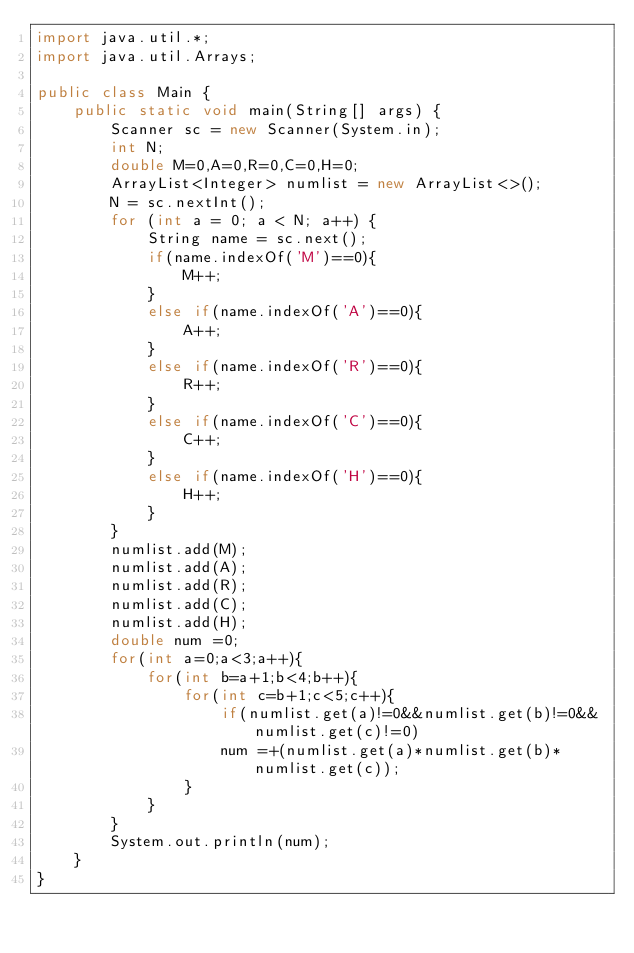Convert code to text. <code><loc_0><loc_0><loc_500><loc_500><_Java_>import java.util.*;
import java.util.Arrays;

public class Main {
    public static void main(String[] args) {
        Scanner sc = new Scanner(System.in);
        int N;
        double M=0,A=0,R=0,C=0,H=0;
        ArrayList<Integer> numlist = new ArrayList<>();
        N = sc.nextInt();
        for (int a = 0; a < N; a++) {
            String name = sc.next();
            if(name.indexOf('M')==0){
                M++;
            }
            else if(name.indexOf('A')==0){
                A++;
            }
            else if(name.indexOf('R')==0){
                R++;
            }
            else if(name.indexOf('C')==0){
                C++;
            }
            else if(name.indexOf('H')==0){
                H++;
            }
        }
        numlist.add(M);
        numlist.add(A);
        numlist.add(R);
        numlist.add(C);
        numlist.add(H);
        double num =0;
        for(int a=0;a<3;a++){
            for(int b=a+1;b<4;b++){
                for(int c=b+1;c<5;c++){
                    if(numlist.get(a)!=0&&numlist.get(b)!=0&&numlist.get(c)!=0)
                    num =+(numlist.get(a)*numlist.get(b)*numlist.get(c));
                }
            }
        }
        System.out.println(num);
    }
}
</code> 